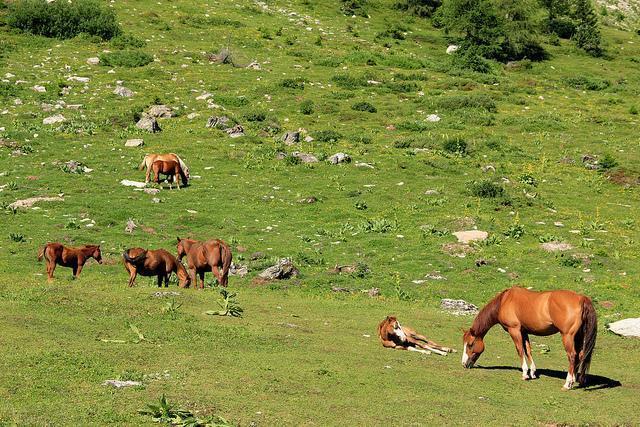How many horses can be seen?
Give a very brief answer. 1. 